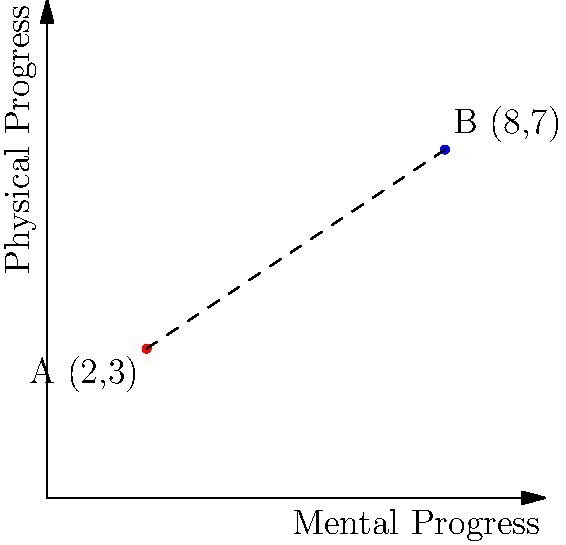On a coordinate plane representing mental progress (x-axis) and physical progress (y-axis) in your journey of self-improvement, two points are marked: A(2,3) representing your starting point, and B(8,7) representing your current state. Calculate the distance between these two points to quantify your overall progress. Round your answer to two decimal places. To find the distance between two points on a coordinate plane, we can use the distance formula, which is derived from the Pythagorean theorem:

$$ d = \sqrt{(x_2 - x_1)^2 + (y_2 - y_1)^2} $$

Where $(x_1, y_1)$ are the coordinates of the first point and $(x_2, y_2)$ are the coordinates of the second point.

Let's plug in our values:
- Point A: $(x_1, y_1) = (2, 3)$
- Point B: $(x_2, y_2) = (8, 7)$

Now, let's calculate:

1) First, find the differences:
   $x_2 - x_1 = 8 - 2 = 6$
   $y_2 - y_1 = 7 - 3 = 4$

2) Square these differences:
   $(x_2 - x_1)^2 = 6^2 = 36$
   $(y_2 - y_1)^2 = 4^2 = 16$

3) Sum the squared differences:
   $36 + 16 = 52$

4) Take the square root:
   $\sqrt{52} \approx 7.21110255092798$

5) Round to two decimal places:
   $7.21$

Therefore, the distance between points A and B, representing your overall progress, is approximately 7.21 units.
Answer: 7.21 